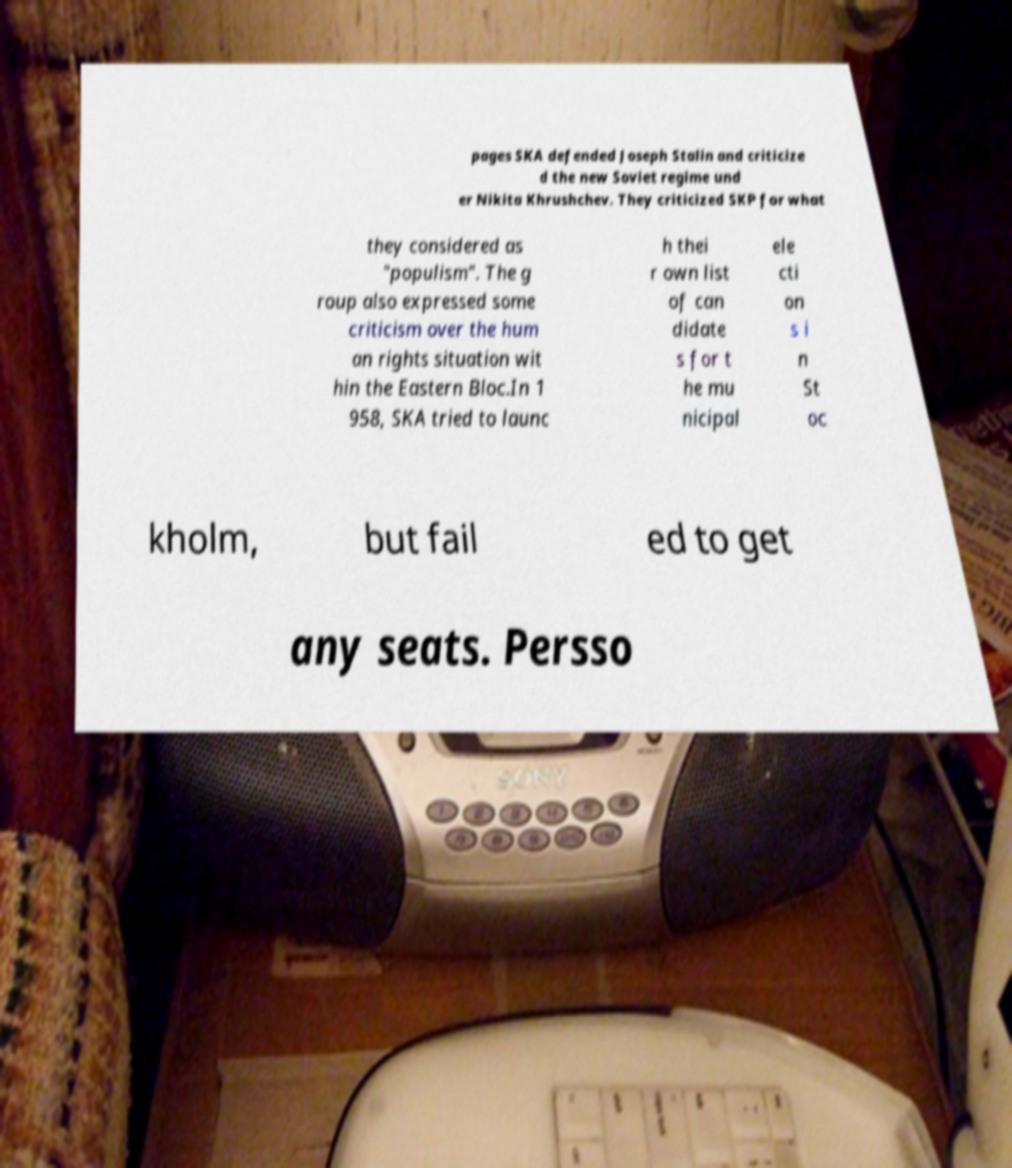What messages or text are displayed in this image? I need them in a readable, typed format. pages SKA defended Joseph Stalin and criticize d the new Soviet regime und er Nikita Khrushchev. They criticized SKP for what they considered as "populism". The g roup also expressed some criticism over the hum an rights situation wit hin the Eastern Bloc.In 1 958, SKA tried to launc h thei r own list of can didate s for t he mu nicipal ele cti on s i n St oc kholm, but fail ed to get any seats. Persso 